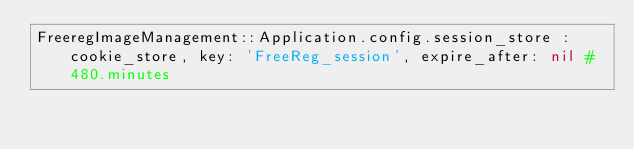<code> <loc_0><loc_0><loc_500><loc_500><_Ruby_>FreeregImageManagement::Application.config.session_store :cookie_store, key: 'FreeReg_session', expire_after: nil #480.minutes

</code> 